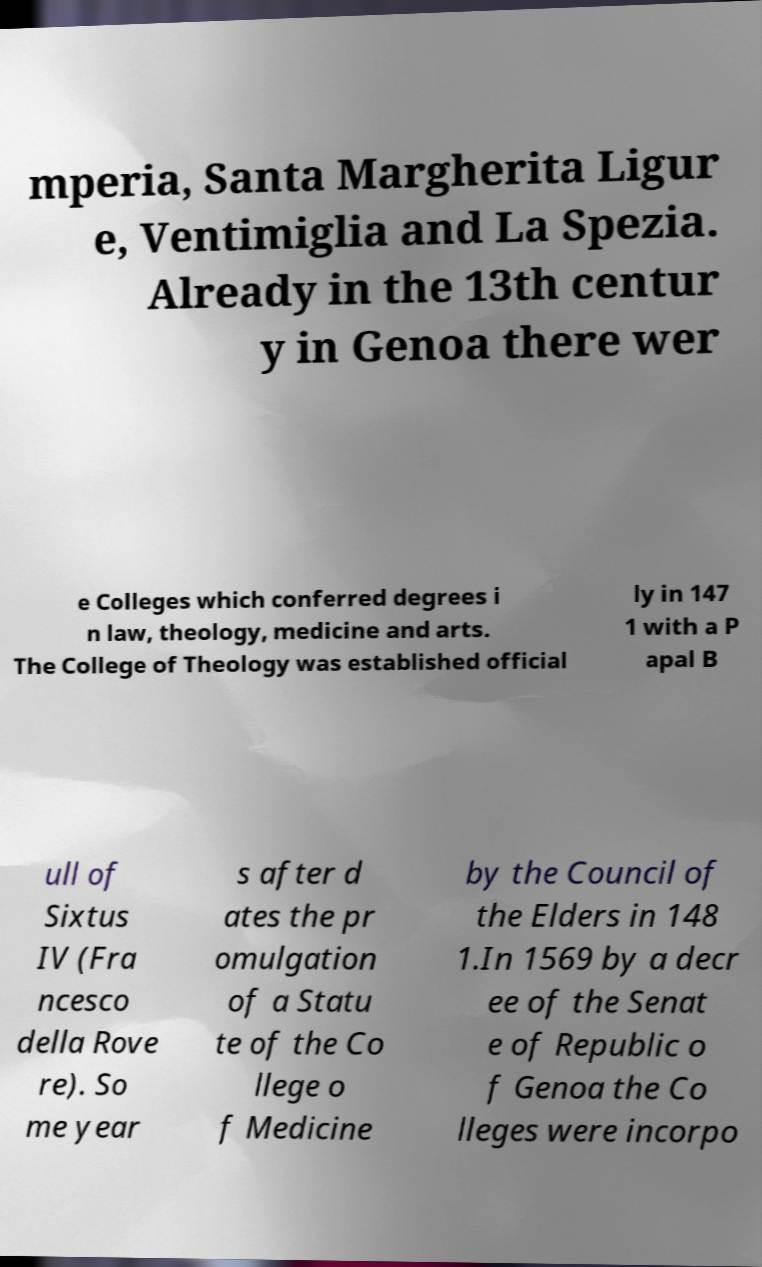I need the written content from this picture converted into text. Can you do that? mperia, Santa Margherita Ligur e, Ventimiglia and La Spezia. Already in the 13th centur y in Genoa there wer e Colleges which conferred degrees i n law, theology, medicine and arts. The College of Theology was established official ly in 147 1 with a P apal B ull of Sixtus IV (Fra ncesco della Rove re). So me year s after d ates the pr omulgation of a Statu te of the Co llege o f Medicine by the Council of the Elders in 148 1.In 1569 by a decr ee of the Senat e of Republic o f Genoa the Co lleges were incorpo 